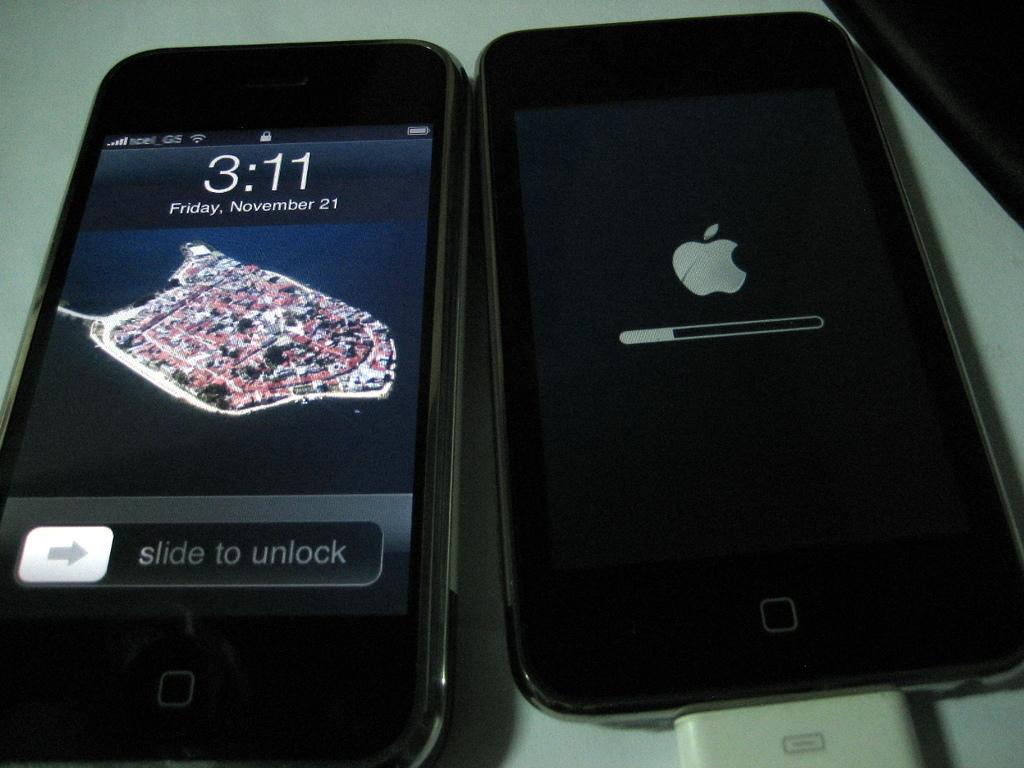<image>
Give a short and clear explanation of the subsequent image. a cell phone with the words Slide to Unlock on it 